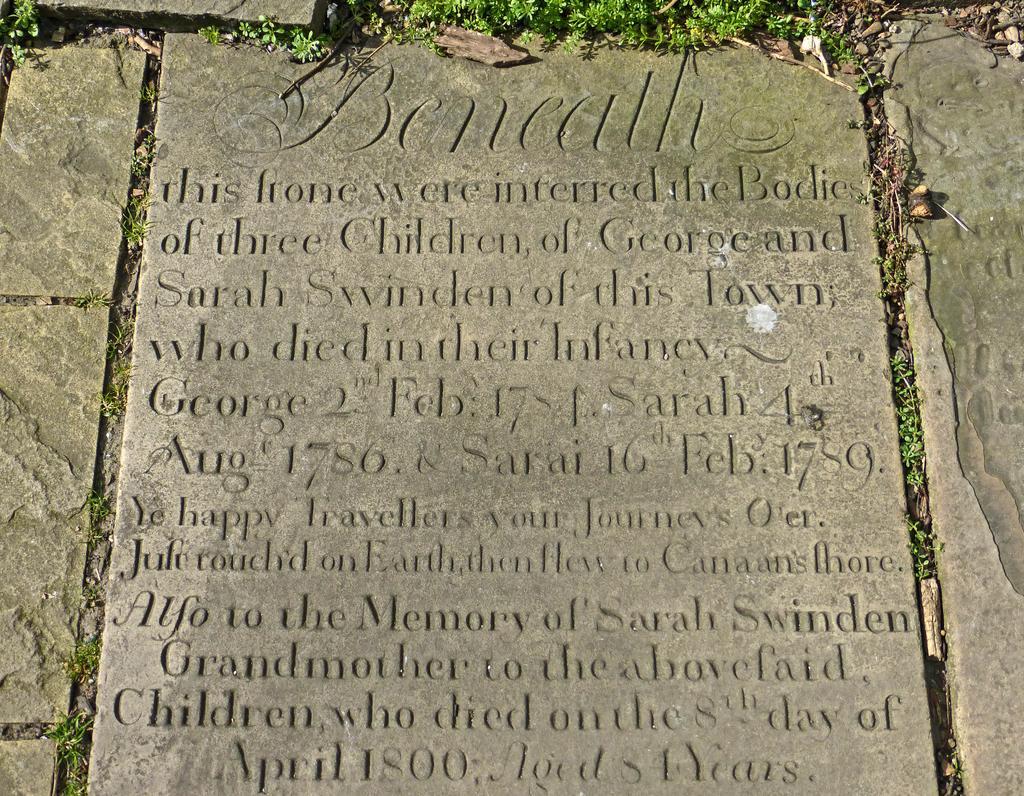Can you describe this image briefly? In this image, we can see few stones and grass. There is something that is written on the stone. Here we can see text and numerical numbers. 